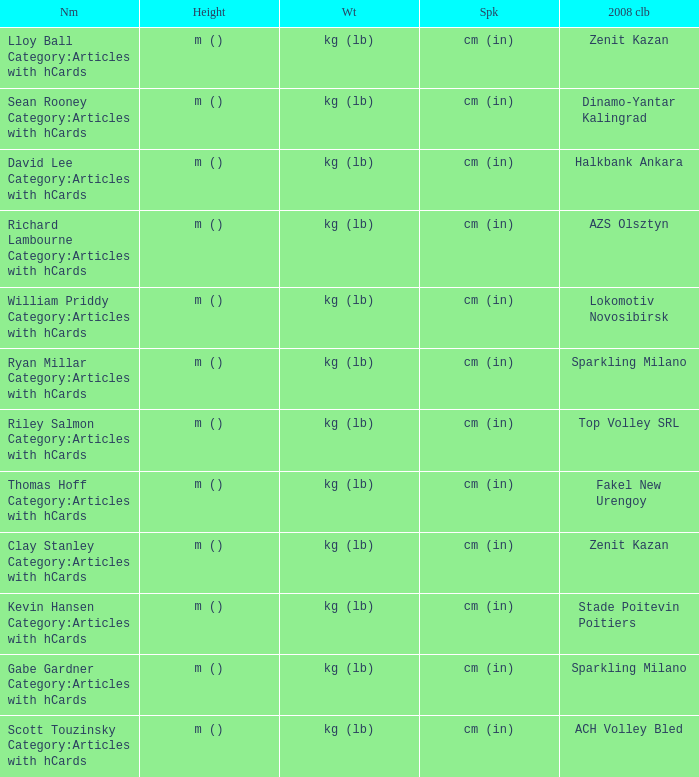What is the name for the 2008 club of Azs olsztyn? Richard Lambourne Category:Articles with hCards. 